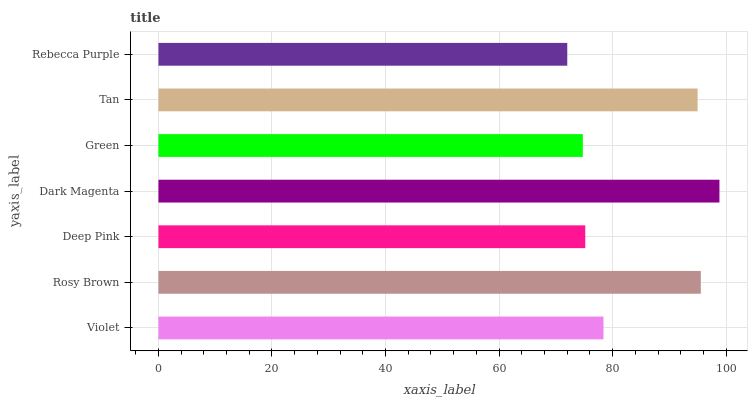Is Rebecca Purple the minimum?
Answer yes or no. Yes. Is Dark Magenta the maximum?
Answer yes or no. Yes. Is Rosy Brown the minimum?
Answer yes or no. No. Is Rosy Brown the maximum?
Answer yes or no. No. Is Rosy Brown greater than Violet?
Answer yes or no. Yes. Is Violet less than Rosy Brown?
Answer yes or no. Yes. Is Violet greater than Rosy Brown?
Answer yes or no. No. Is Rosy Brown less than Violet?
Answer yes or no. No. Is Violet the high median?
Answer yes or no. Yes. Is Violet the low median?
Answer yes or no. Yes. Is Rebecca Purple the high median?
Answer yes or no. No. Is Rosy Brown the low median?
Answer yes or no. No. 